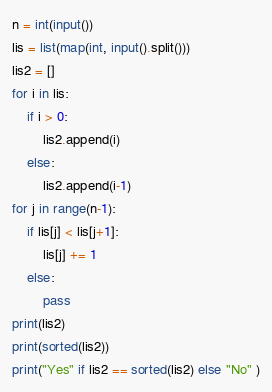Convert code to text. <code><loc_0><loc_0><loc_500><loc_500><_Python_>n = int(input())
lis = list(map(int, input().split()))
lis2 = []
for i in lis:
    if i > 0:
        lis2.append(i)
    else:
        lis2.append(i-1)
for j in range(n-1):
    if lis[j] < lis[j+1]:
        lis[j] += 1
    else:
        pass
print(lis2)
print(sorted(lis2))
print("Yes" if lis2 == sorted(lis2) else "No" )</code> 